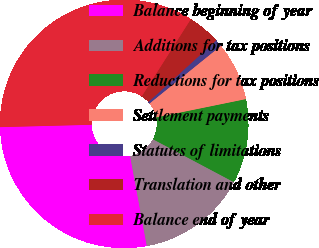Convert chart. <chart><loc_0><loc_0><loc_500><loc_500><pie_chart><fcel>Balance beginning of year<fcel>Additions for tax positions<fcel>Reductions for tax positions<fcel>Settlement payments<fcel>Statutes of limitations<fcel>Translation and other<fcel>Balance end of year<nl><fcel>27.51%<fcel>14.32%<fcel>10.97%<fcel>7.61%<fcel>0.91%<fcel>4.26%<fcel>34.43%<nl></chart> 